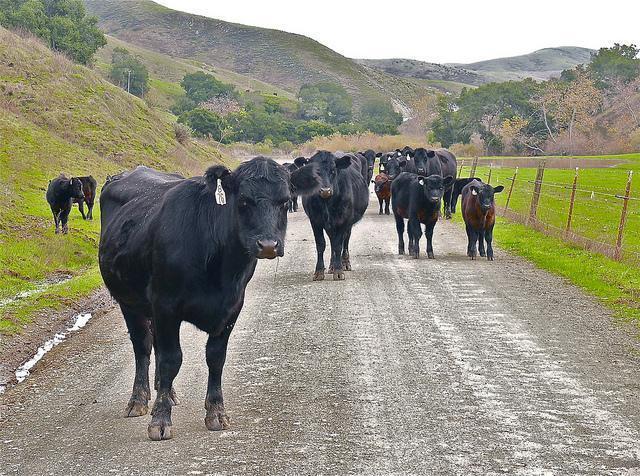How many cows are in the picture?
Give a very brief answer. 4. How many people riding bikes?
Give a very brief answer. 0. 